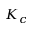Convert formula to latex. <formula><loc_0><loc_0><loc_500><loc_500>K _ { c }</formula> 